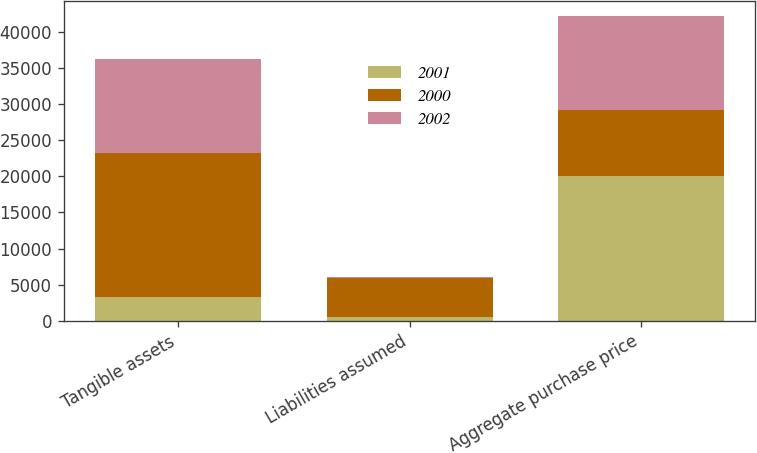Convert chart. <chart><loc_0><loc_0><loc_500><loc_500><stacked_bar_chart><ecel><fcel>Tangible assets<fcel>Liabilities assumed<fcel>Aggregate purchase price<nl><fcel>2001<fcel>3360<fcel>518<fcel>20077<nl><fcel>2000<fcel>19886<fcel>5404<fcel>9149.5<nl><fcel>2002<fcel>13006<fcel>111<fcel>12895<nl></chart> 